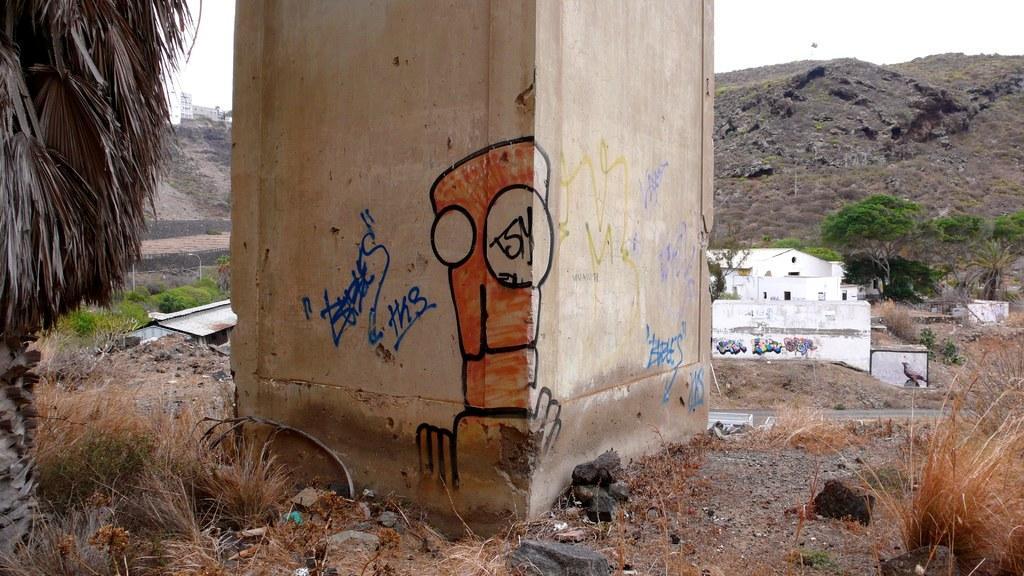Could you give a brief overview of what you see in this image? On the left side of the image we can see the dried leaves, grass and buildings. In the middle of the image we can see the pillar on which some text is written and some stones. On the right side of the image we can see hills, building, grass and read. 